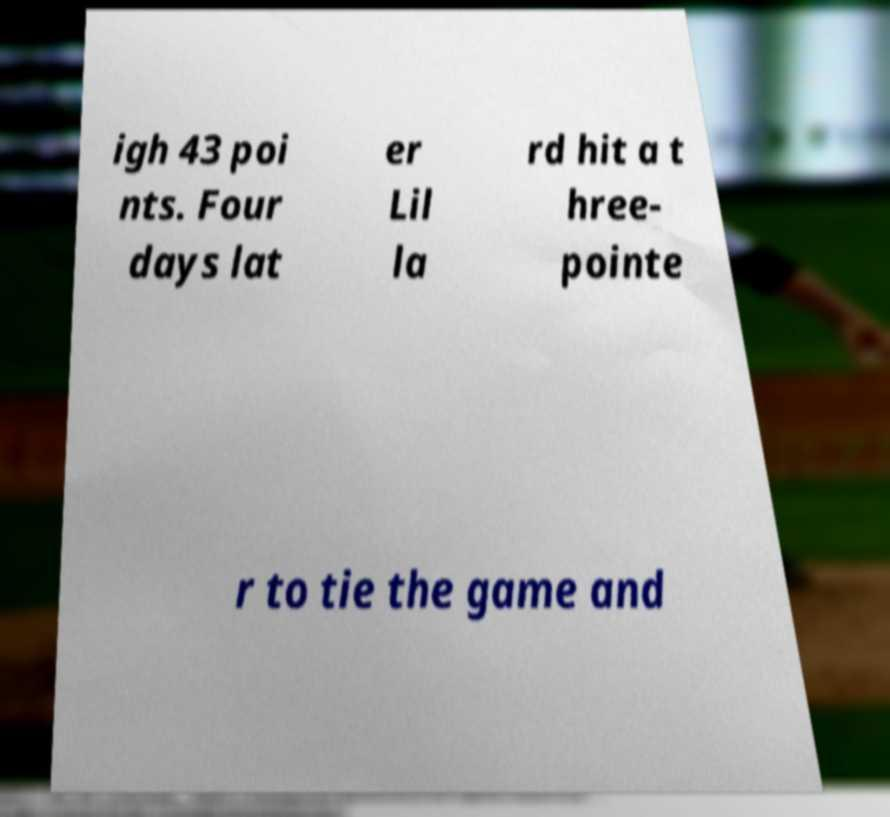Could you extract and type out the text from this image? igh 43 poi nts. Four days lat er Lil la rd hit a t hree- pointe r to tie the game and 